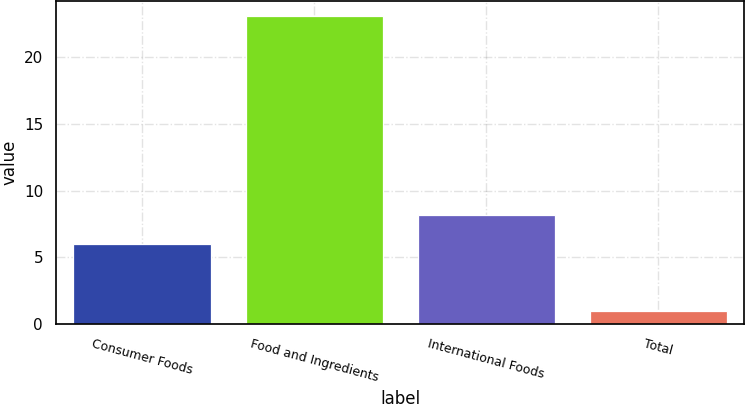<chart> <loc_0><loc_0><loc_500><loc_500><bar_chart><fcel>Consumer Foods<fcel>Food and Ingredients<fcel>International Foods<fcel>Total<nl><fcel>6<fcel>23<fcel>8.2<fcel>1<nl></chart> 